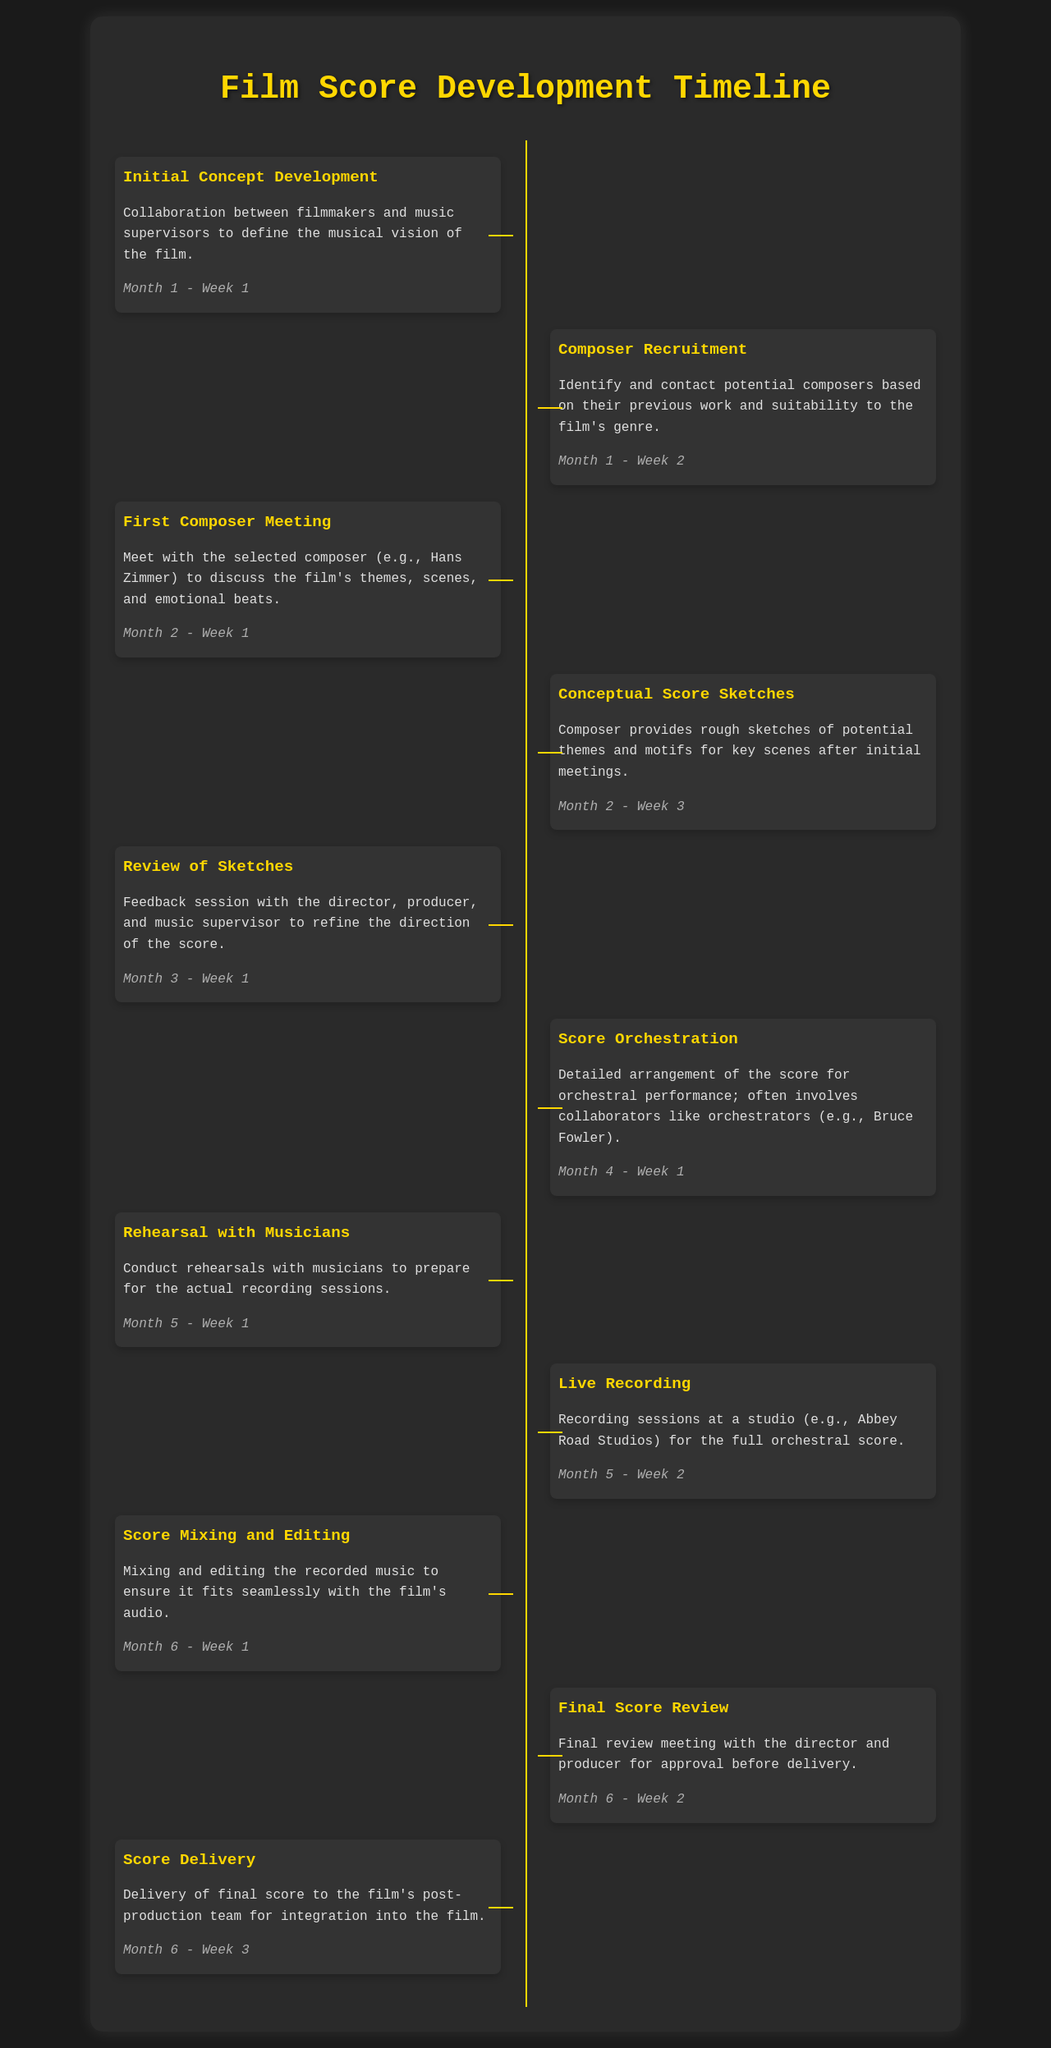What is the first milestone in the timeline? The first milestone in the timeline is "Initial Concept Development," which involves collaboration between filmmakers and music supervisors.
Answer: Initial Concept Development When does the first composer meeting occur? The first composer meeting occurs in Month 2 - Week 1, where the selected composer discusses the film's themes and emotional beats.
Answer: Month 2 - Week 1 Who provides the score orchestration? The score orchestration often involves collaborators like orchestrators, specifically mentioned in the document as Bruce Fowler.
Answer: Bruce Fowler How long after the initial concept development does the score delivery take place? The score delivery takes place after six milestones, occurring in Month 6 - Week 3, which is approximately six months after the initial concept development in Month 1.
Answer: Six months What is the focus of the rehearsal with musicians? The focus of the rehearsal with musicians is to prepare for the actual recording sessions.
Answer: Prepare for recording sessions What happens during the score mixing and editing? During the score mixing and editing, the recorded music is mixed and edited to ensure it fits seamlessly with the film's audio.
Answer: Fits seamlessly with the film's audio In which month is the review of sketches conducted? The review of sketches is conducted in Month 3 - Week 1, involving feedback from the director, producer, and music supervisor.
Answer: Month 3 - Week 1 Which studio is mentioned for the live recording? The studio mentioned for the live recording is Abbey Road Studios.
Answer: Abbey Road Studios What is the main purpose of the final score review? The main purpose of the final score review is to obtain approval from the director and producer before delivery.
Answer: Approval before delivery 